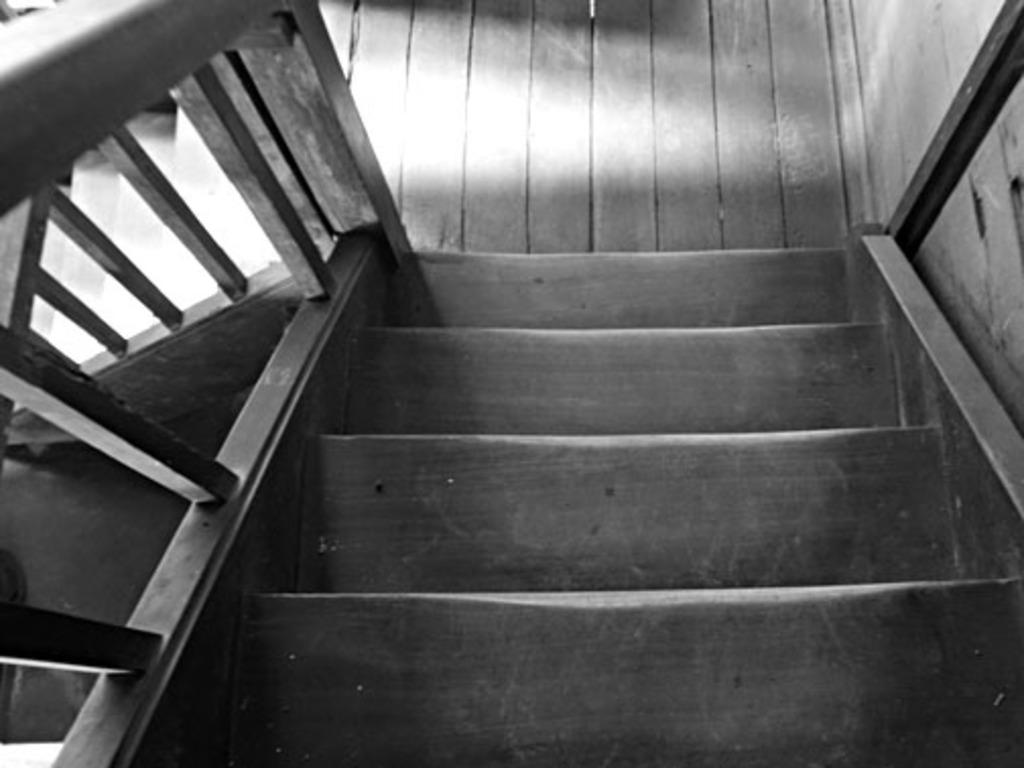What type of structure is present in the image? There is a wooden staircase in the image. Is there any additional feature associated with the staircase? Yes, there is fencing associated with the staircase. What type of religious symbol can be seen on the wooden staircase in the image? There is no religious symbol present on the wooden staircase in the image. Can you hear a guitar being played in the background of the image? There is no mention of a guitar or any sound in the image, so it cannot be determined if one is present or being played. 